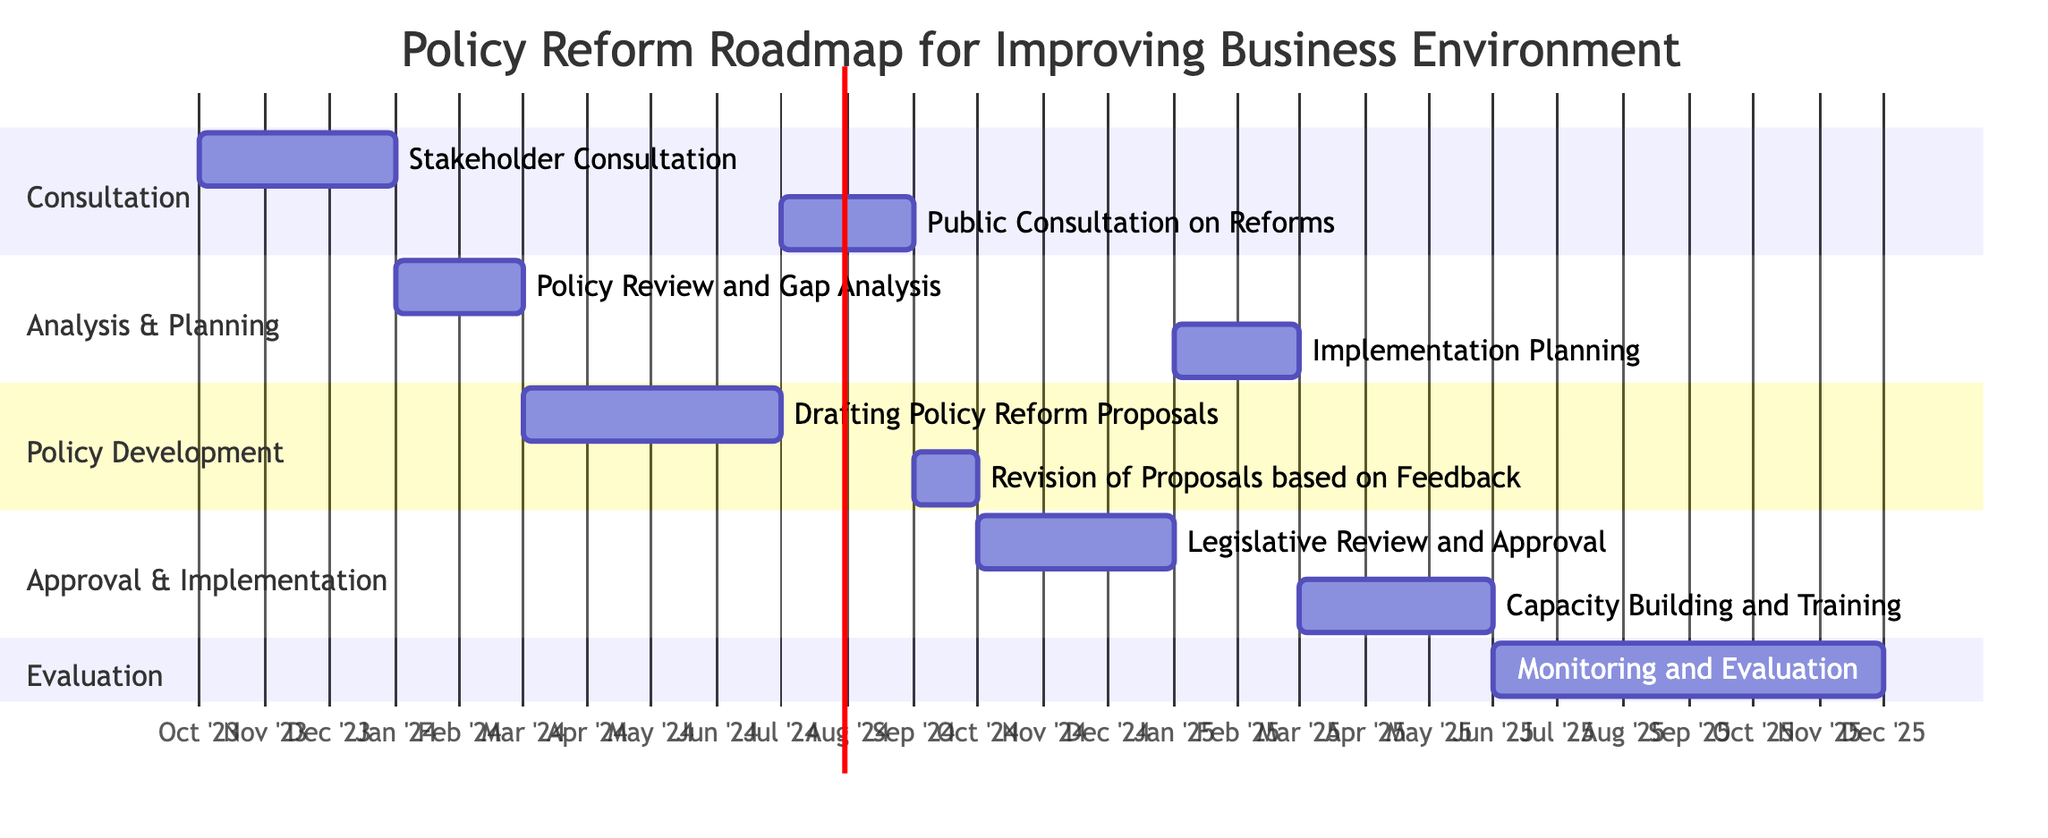What's the duration of the "Stakeholder Consultation"? The "Stakeholder Consultation" is scheduled to last for 3 months, beginning on October 1, 2023, and ending on December 31, 2023.
Answer: 3 months What follows after the "Policy Review and Gap Analysis"? The task that follows after "Policy Review and Gap Analysis" is "Drafting Policy Reform Proposals." This is indicated by the dependency relationship in the Gantt chart.
Answer: Drafting Policy Reform Proposals How many months does the "Legislative Review and Approval" take? "Legislative Review and Approval" has a duration of 3 months, starting on October 1, 2024, and ending on December 31, 2024.
Answer: 3 months What is the start date of the "Monitoring and Evaluation"? "Monitoring and Evaluation" starts on June 1, 2025, following the completion of "Capacity Building and Training."
Answer: June 1, 2025 Which task is dependent on the "Public Consultation on Reforms"? The task that is dependent on "Public Consultation on Reforms" is "Revision of Proposals based on Feedback", meaning it cannot start until the public consultation is completed.
Answer: Revision of Proposals based on Feedback What are the two sections in the diagram that deal with "Planning"? The two sections that deal with "Planning" are "Analysis & Planning" and "Implementation Planning." The first deals with reviewing and gap analysis, while the second deals with planning for implementation.
Answer: Analysis & Planning, Implementation Planning How long is the total duration for "Capacity Building and Training" and "Monitoring and Evaluation" combined? "Capacity Building and Training" lasts for 3 months and "Monitoring and Evaluation" lasts for 6 months, hence the total duration is 3 plus 6, which equals 9 months.
Answer: 9 months Which task has the longest duration on the chart? The task with the longest duration is "Monitoring and Evaluation," which takes 6 months.
Answer: Monitoring and Evaluation What is the start date of the "Drafting Policy Reform Proposals"? "Drafting Policy Reform Proposals" starts on March 1, 2024, following the completion of the "Policy Review and Gap Analysis."
Answer: March 1, 2024 